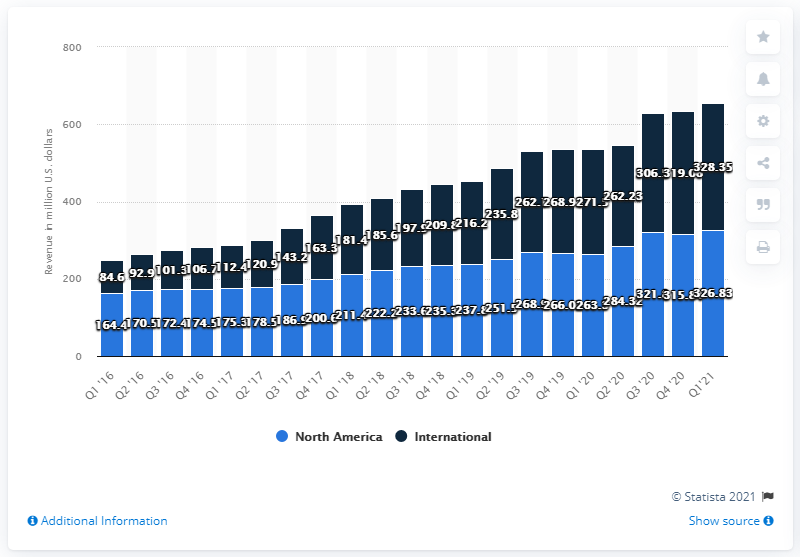Highlight a few significant elements in this photo. The most recent North American revenue of the Match Group was $326.83 million. 